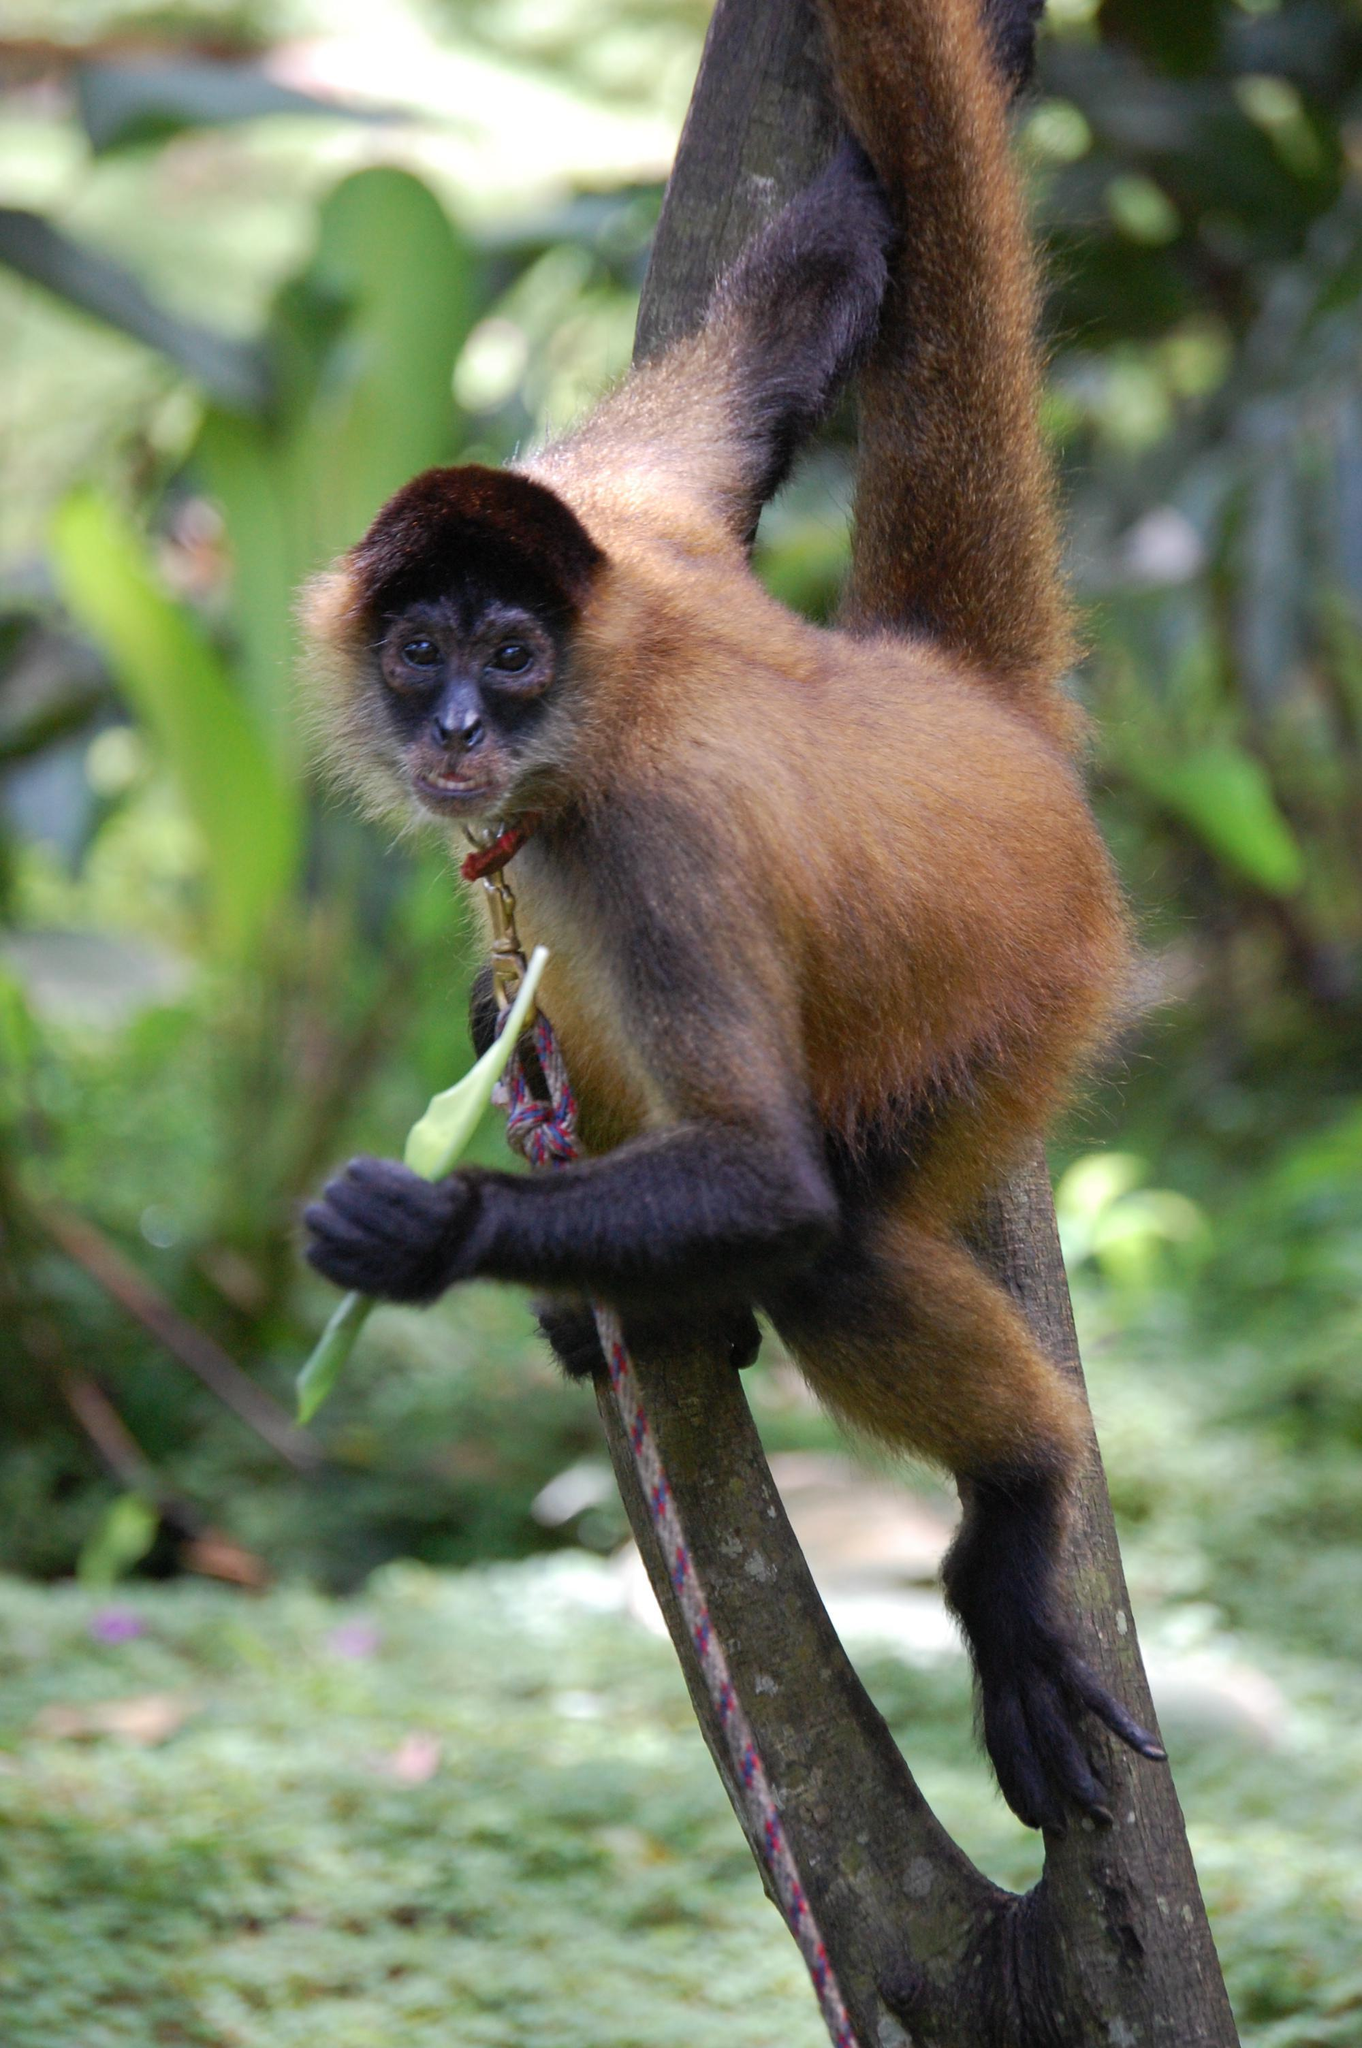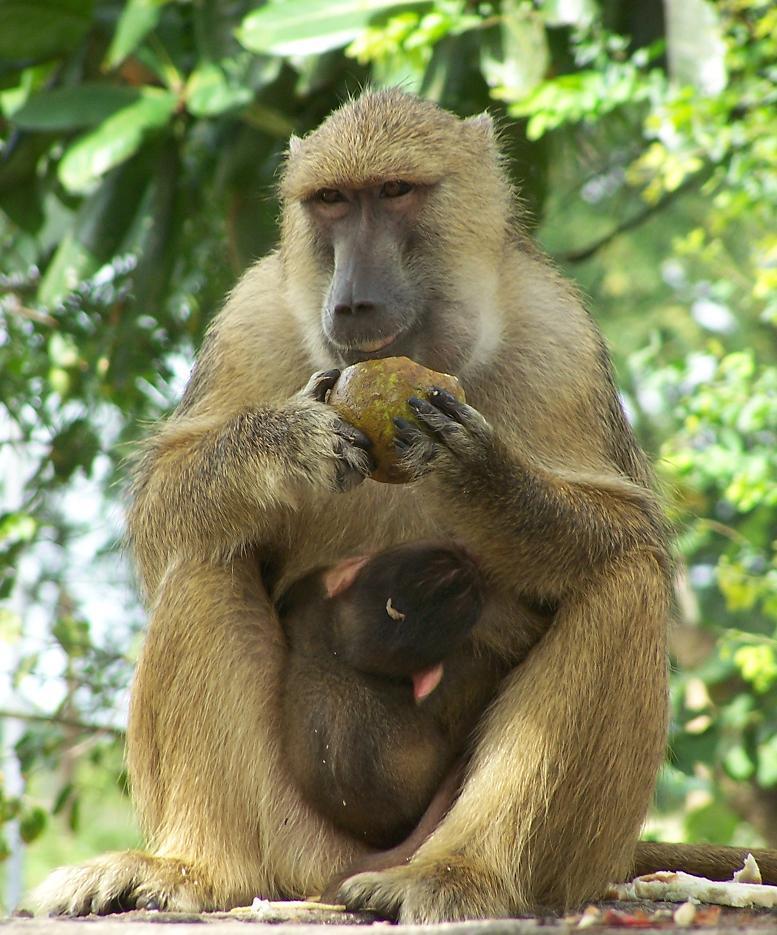The first image is the image on the left, the second image is the image on the right. Given the left and right images, does the statement "At least one monkey is on all fours." hold true? Answer yes or no. No. 